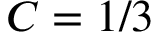Convert formula to latex. <formula><loc_0><loc_0><loc_500><loc_500>C = 1 / 3</formula> 